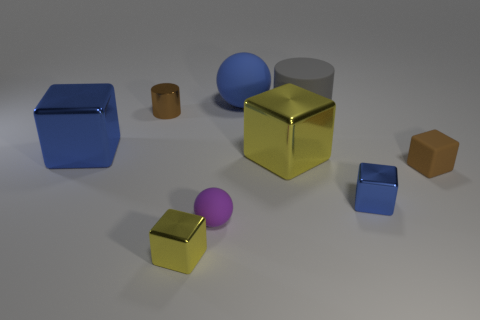Subtract all blue cylinders. How many yellow cubes are left? 2 Subtract all large blue cubes. How many cubes are left? 4 Subtract 1 cubes. How many cubes are left? 4 Subtract all blue blocks. How many blocks are left? 3 Subtract all balls. How many objects are left? 7 Subtract all cyan cubes. Subtract all red cylinders. How many cubes are left? 5 Subtract all tiny rubber things. Subtract all big spheres. How many objects are left? 6 Add 1 blue matte objects. How many blue matte objects are left? 2 Add 7 yellow shiny objects. How many yellow shiny objects exist? 9 Subtract 1 purple spheres. How many objects are left? 8 